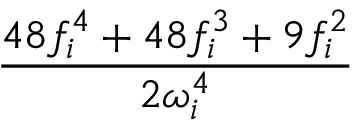<formula> <loc_0><loc_0><loc_500><loc_500>\frac { 4 8 f _ { i } ^ { 4 } + 4 8 f _ { i } ^ { 3 } + 9 f _ { i } ^ { 2 } } { 2 \omega _ { i } ^ { 4 } }</formula> 